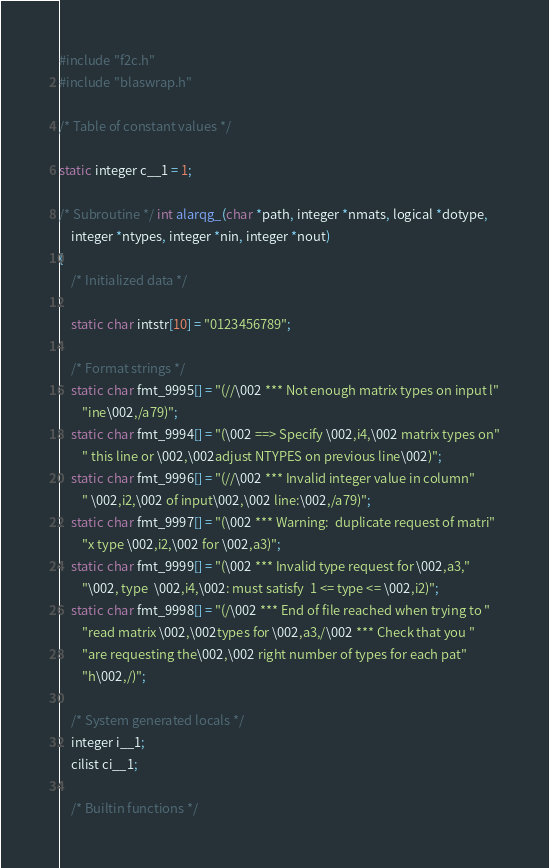<code> <loc_0><loc_0><loc_500><loc_500><_C_>#include "f2c.h"
#include "blaswrap.h"

/* Table of constant values */

static integer c__1 = 1;

/* Subroutine */ int alarqg_(char *path, integer *nmats, logical *dotype, 
	integer *ntypes, integer *nin, integer *nout)
{
    /* Initialized data */

    static char intstr[10] = "0123456789";

    /* Format strings */
    static char fmt_9995[] = "(//\002 *** Not enough matrix types on input l"
	    "ine\002,/a79)";
    static char fmt_9994[] = "(\002 ==> Specify \002,i4,\002 matrix types on"
	    " this line or \002,\002adjust NTYPES on previous line\002)";
    static char fmt_9996[] = "(//\002 *** Invalid integer value in column"
	    " \002,i2,\002 of input\002,\002 line:\002,/a79)";
    static char fmt_9997[] = "(\002 *** Warning:  duplicate request of matri"
	    "x type \002,i2,\002 for \002,a3)";
    static char fmt_9999[] = "(\002 *** Invalid type request for \002,a3,"
	    "\002, type  \002,i4,\002: must satisfy  1 <= type <= \002,i2)";
    static char fmt_9998[] = "(/\002 *** End of file reached when trying to "
	    "read matrix \002,\002types for \002,a3,/\002 *** Check that you "
	    "are requesting the\002,\002 right number of types for each pat"
	    "h\002,/)";

    /* System generated locals */
    integer i__1;
    cilist ci__1;

    /* Builtin functions */</code> 